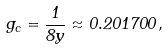Convert formula to latex. <formula><loc_0><loc_0><loc_500><loc_500>g _ { c } = \frac { 1 } { 8 y } \approx 0 . 2 0 1 7 0 0 \, ,</formula> 